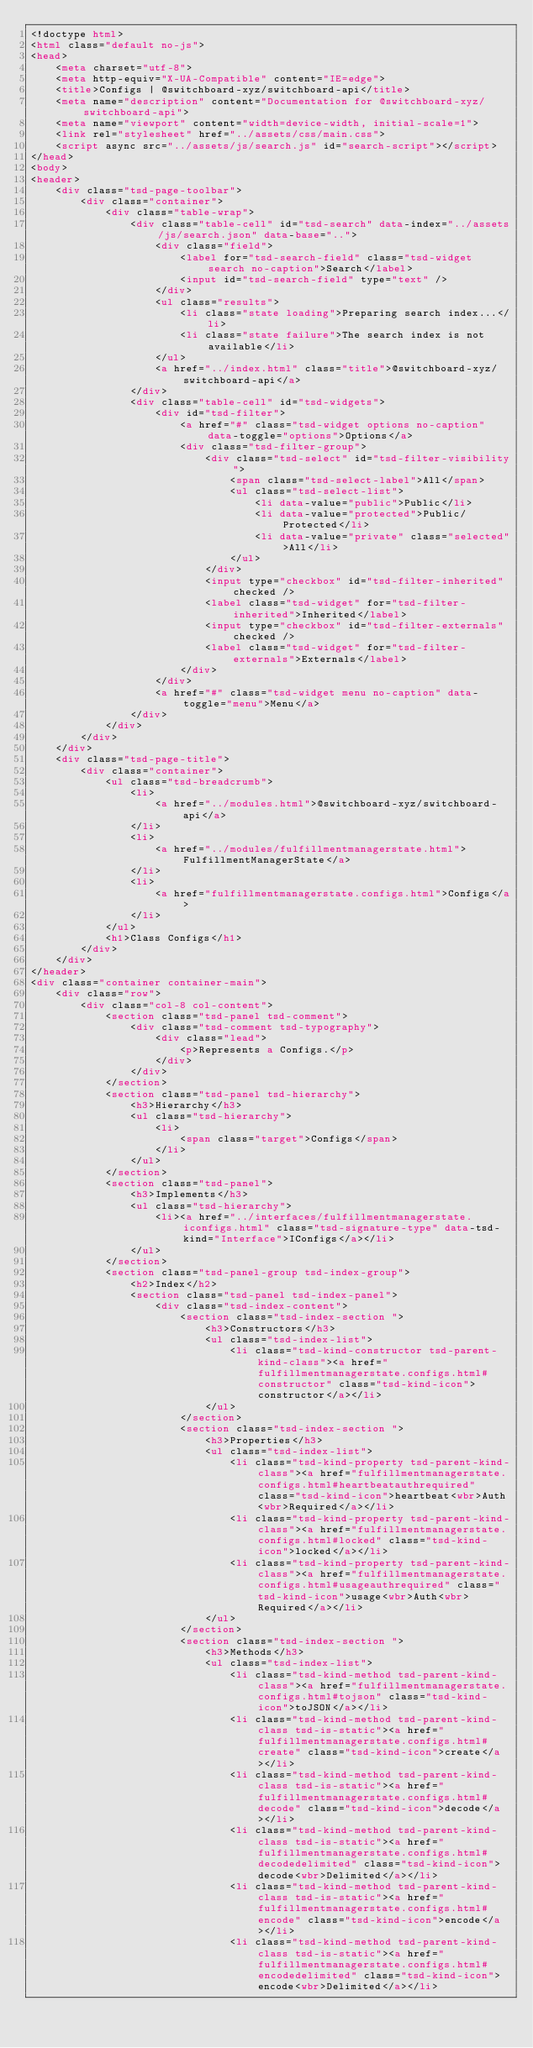<code> <loc_0><loc_0><loc_500><loc_500><_HTML_><!doctype html>
<html class="default no-js">
<head>
	<meta charset="utf-8">
	<meta http-equiv="X-UA-Compatible" content="IE=edge">
	<title>Configs | @switchboard-xyz/switchboard-api</title>
	<meta name="description" content="Documentation for @switchboard-xyz/switchboard-api">
	<meta name="viewport" content="width=device-width, initial-scale=1">
	<link rel="stylesheet" href="../assets/css/main.css">
	<script async src="../assets/js/search.js" id="search-script"></script>
</head>
<body>
<header>
	<div class="tsd-page-toolbar">
		<div class="container">
			<div class="table-wrap">
				<div class="table-cell" id="tsd-search" data-index="../assets/js/search.json" data-base="..">
					<div class="field">
						<label for="tsd-search-field" class="tsd-widget search no-caption">Search</label>
						<input id="tsd-search-field" type="text" />
					</div>
					<ul class="results">
						<li class="state loading">Preparing search index...</li>
						<li class="state failure">The search index is not available</li>
					</ul>
					<a href="../index.html" class="title">@switchboard-xyz/switchboard-api</a>
				</div>
				<div class="table-cell" id="tsd-widgets">
					<div id="tsd-filter">
						<a href="#" class="tsd-widget options no-caption" data-toggle="options">Options</a>
						<div class="tsd-filter-group">
							<div class="tsd-select" id="tsd-filter-visibility">
								<span class="tsd-select-label">All</span>
								<ul class="tsd-select-list">
									<li data-value="public">Public</li>
									<li data-value="protected">Public/Protected</li>
									<li data-value="private" class="selected">All</li>
								</ul>
							</div>
							<input type="checkbox" id="tsd-filter-inherited" checked />
							<label class="tsd-widget" for="tsd-filter-inherited">Inherited</label>
							<input type="checkbox" id="tsd-filter-externals" checked />
							<label class="tsd-widget" for="tsd-filter-externals">Externals</label>
						</div>
					</div>
					<a href="#" class="tsd-widget menu no-caption" data-toggle="menu">Menu</a>
				</div>
			</div>
		</div>
	</div>
	<div class="tsd-page-title">
		<div class="container">
			<ul class="tsd-breadcrumb">
				<li>
					<a href="../modules.html">@switchboard-xyz/switchboard-api</a>
				</li>
				<li>
					<a href="../modules/fulfillmentmanagerstate.html">FulfillmentManagerState</a>
				</li>
				<li>
					<a href="fulfillmentmanagerstate.configs.html">Configs</a>
				</li>
			</ul>
			<h1>Class Configs</h1>
		</div>
	</div>
</header>
<div class="container container-main">
	<div class="row">
		<div class="col-8 col-content">
			<section class="tsd-panel tsd-comment">
				<div class="tsd-comment tsd-typography">
					<div class="lead">
						<p>Represents a Configs.</p>
					</div>
				</div>
			</section>
			<section class="tsd-panel tsd-hierarchy">
				<h3>Hierarchy</h3>
				<ul class="tsd-hierarchy">
					<li>
						<span class="target">Configs</span>
					</li>
				</ul>
			</section>
			<section class="tsd-panel">
				<h3>Implements</h3>
				<ul class="tsd-hierarchy">
					<li><a href="../interfaces/fulfillmentmanagerstate.iconfigs.html" class="tsd-signature-type" data-tsd-kind="Interface">IConfigs</a></li>
				</ul>
			</section>
			<section class="tsd-panel-group tsd-index-group">
				<h2>Index</h2>
				<section class="tsd-panel tsd-index-panel">
					<div class="tsd-index-content">
						<section class="tsd-index-section ">
							<h3>Constructors</h3>
							<ul class="tsd-index-list">
								<li class="tsd-kind-constructor tsd-parent-kind-class"><a href="fulfillmentmanagerstate.configs.html#constructor" class="tsd-kind-icon">constructor</a></li>
							</ul>
						</section>
						<section class="tsd-index-section ">
							<h3>Properties</h3>
							<ul class="tsd-index-list">
								<li class="tsd-kind-property tsd-parent-kind-class"><a href="fulfillmentmanagerstate.configs.html#heartbeatauthrequired" class="tsd-kind-icon">heartbeat<wbr>Auth<wbr>Required</a></li>
								<li class="tsd-kind-property tsd-parent-kind-class"><a href="fulfillmentmanagerstate.configs.html#locked" class="tsd-kind-icon">locked</a></li>
								<li class="tsd-kind-property tsd-parent-kind-class"><a href="fulfillmentmanagerstate.configs.html#usageauthrequired" class="tsd-kind-icon">usage<wbr>Auth<wbr>Required</a></li>
							</ul>
						</section>
						<section class="tsd-index-section ">
							<h3>Methods</h3>
							<ul class="tsd-index-list">
								<li class="tsd-kind-method tsd-parent-kind-class"><a href="fulfillmentmanagerstate.configs.html#tojson" class="tsd-kind-icon">toJSON</a></li>
								<li class="tsd-kind-method tsd-parent-kind-class tsd-is-static"><a href="fulfillmentmanagerstate.configs.html#create" class="tsd-kind-icon">create</a></li>
								<li class="tsd-kind-method tsd-parent-kind-class tsd-is-static"><a href="fulfillmentmanagerstate.configs.html#decode" class="tsd-kind-icon">decode</a></li>
								<li class="tsd-kind-method tsd-parent-kind-class tsd-is-static"><a href="fulfillmentmanagerstate.configs.html#decodedelimited" class="tsd-kind-icon">decode<wbr>Delimited</a></li>
								<li class="tsd-kind-method tsd-parent-kind-class tsd-is-static"><a href="fulfillmentmanagerstate.configs.html#encode" class="tsd-kind-icon">encode</a></li>
								<li class="tsd-kind-method tsd-parent-kind-class tsd-is-static"><a href="fulfillmentmanagerstate.configs.html#encodedelimited" class="tsd-kind-icon">encode<wbr>Delimited</a></li></code> 